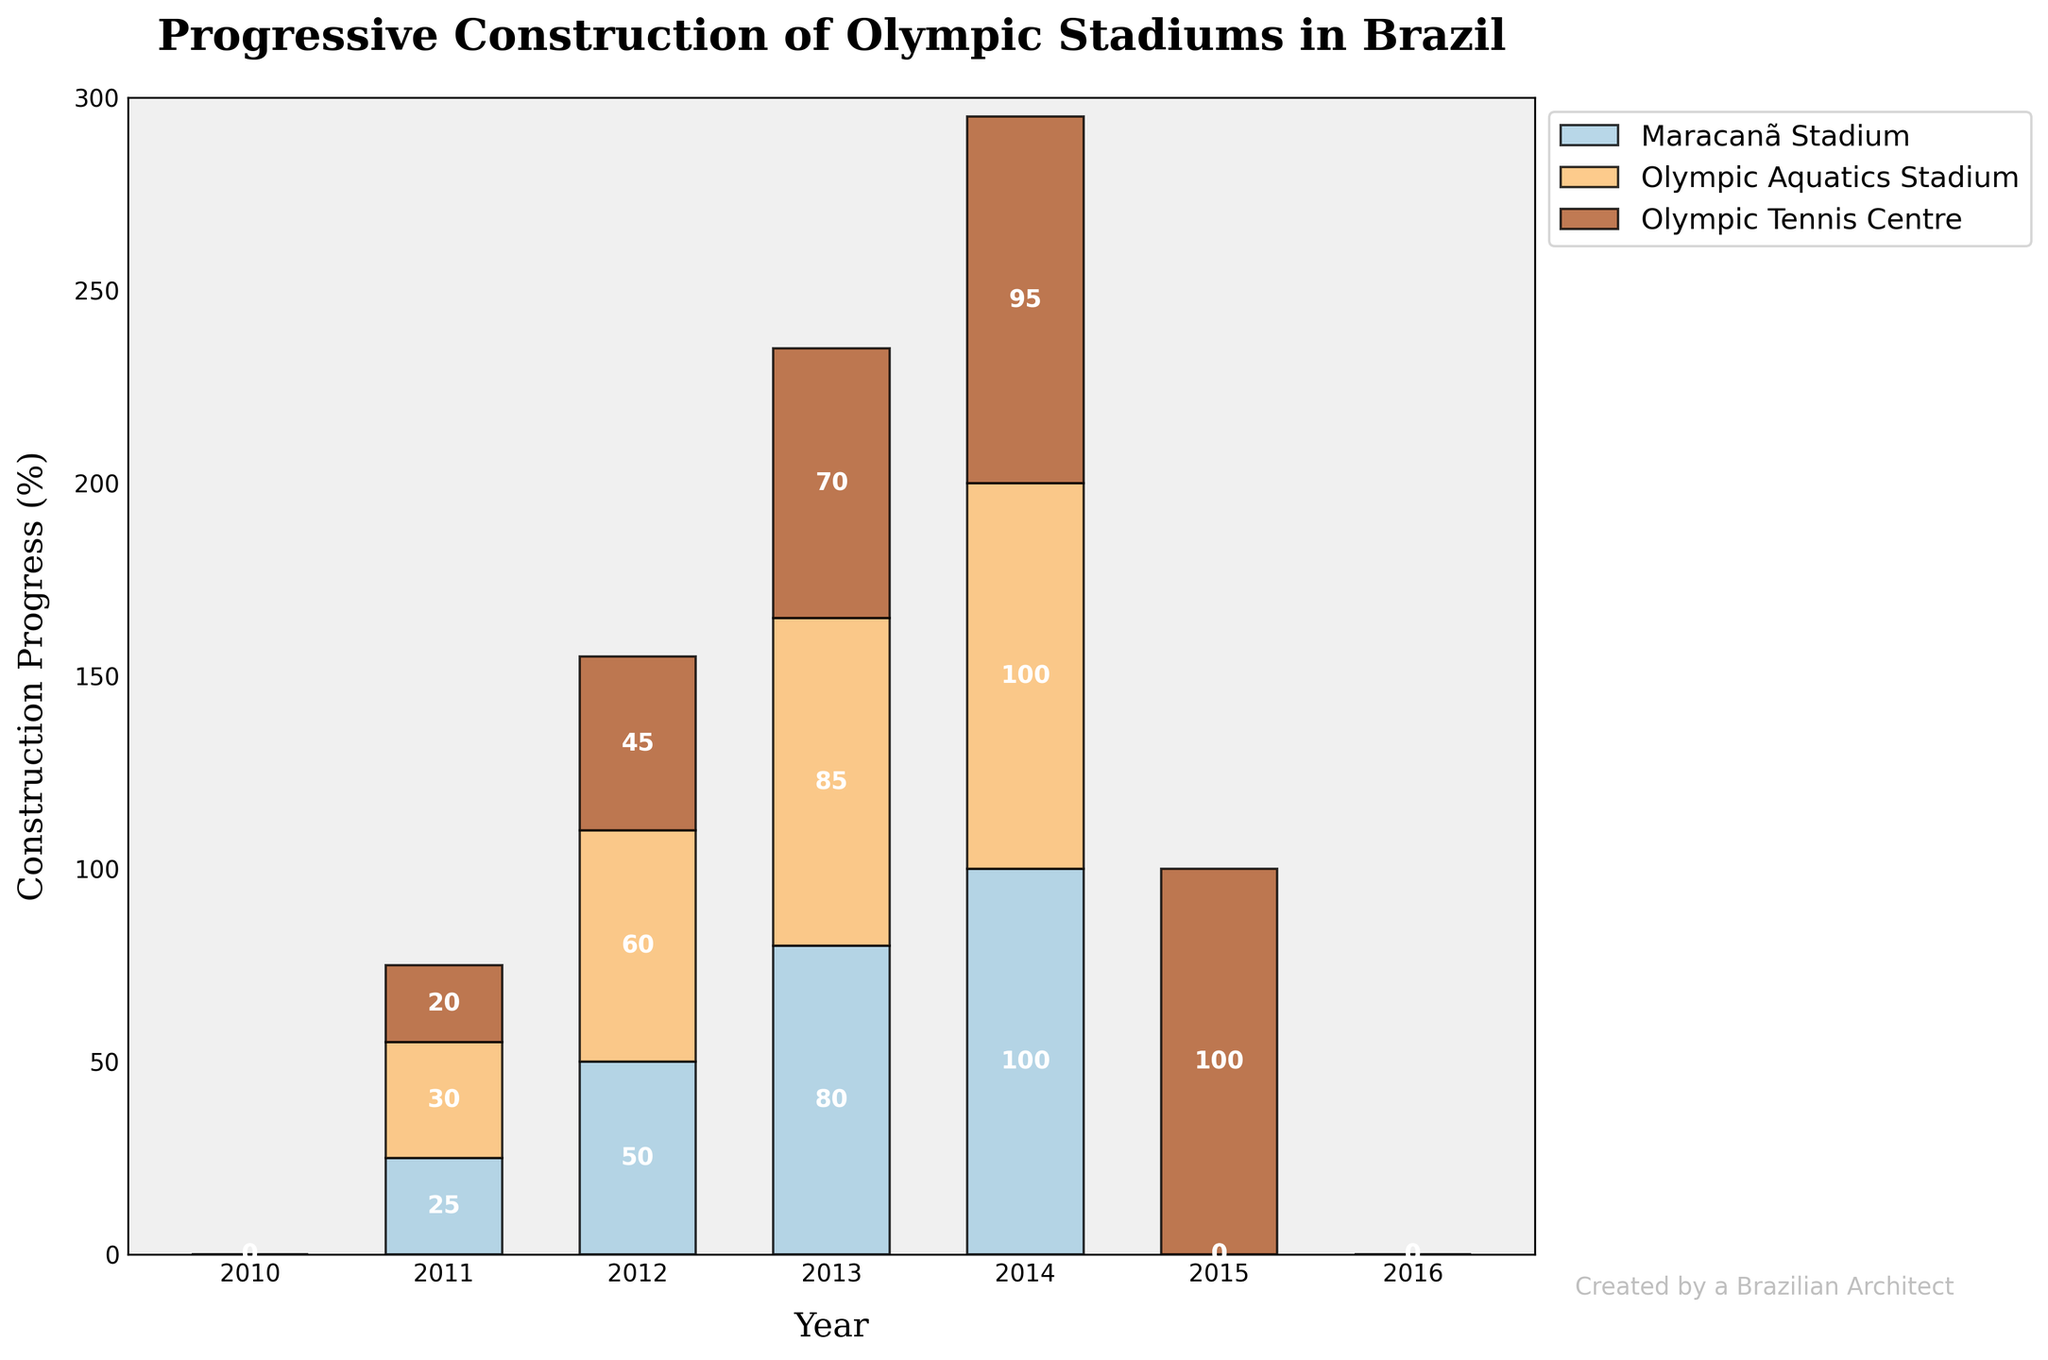What is the title of the plot? The title is located at the top of the figure. It provides a summary of what the figure is about.
Answer: Progressive Construction of Olympic Stadiums in Brazil What is the construction progress of the Maracanã Stadium in 2012? By looking at the x-axis for the year 2012 and identifying the corresponding stack segment for Maracanã Stadium, we see that the value is 50.
Answer: 50% Which stadium had the highest construction progress in 2013? In 2013, check the segments' heights for each stadium. Olympic Aquatics Stadium has 30%, Maracanã Stadium has 80%, and Olympic Tennis Centre has 45%. Maracanã Stadium has the highest progress.
Answer: Maracanã Stadium What is the sum of construction progress for all stadiums in 2015? For 2015, add up the progress values: Maracanã Stadium (100%) + Olympic Aquatics Stadium (85%) + Olympic Tennis Centre (95%). This results in 100 + 85 + 95.
Answer: 280% Compare the construction progress of Olympic Aquatics Stadium and Olympic Tennis Centre in 2014. Which one is higher, and by how much? Olympic Aquatics Stadium has 60% in 2014, and Olympic Tennis Centre has 70%. Subtract to find the difference: 70% - 60% = 10%.
Answer: Olympic Tennis Centre, by 10% In which year did the Maracanã Stadium reach 100% construction progress? Follow the Maracanã Stadium's progress across the years till it hits the maximum value, which is in 2014.
Answer: 2014 From the plot, estimate the average annual construction progress of the Olympic Aquatics Stadium from 2012 to 2016. The total progress from 2012 to 2016 is 0 + 30 + 60 + 85 + 100 = 275. Since this spans over 5 years, we divide 275 by 5.
Answer: 55% By looking at the colors, which stadium is represented by the topmost layer in 2015? The topmost layer of the stacked bar for 2015 is colored differently. Identifying the color from the legend, it corresponds to Olympic Tennis Centre.
Answer: Olympic Tennis Centre What is the construction progress increase for the Olympic Tennis Centre from 2013 to 2014? In 2013, the Olympic Tennis Centre has 45% progress, and in 2014 it has 70%. The difference is 70% - 45%.
Answer: 25% 